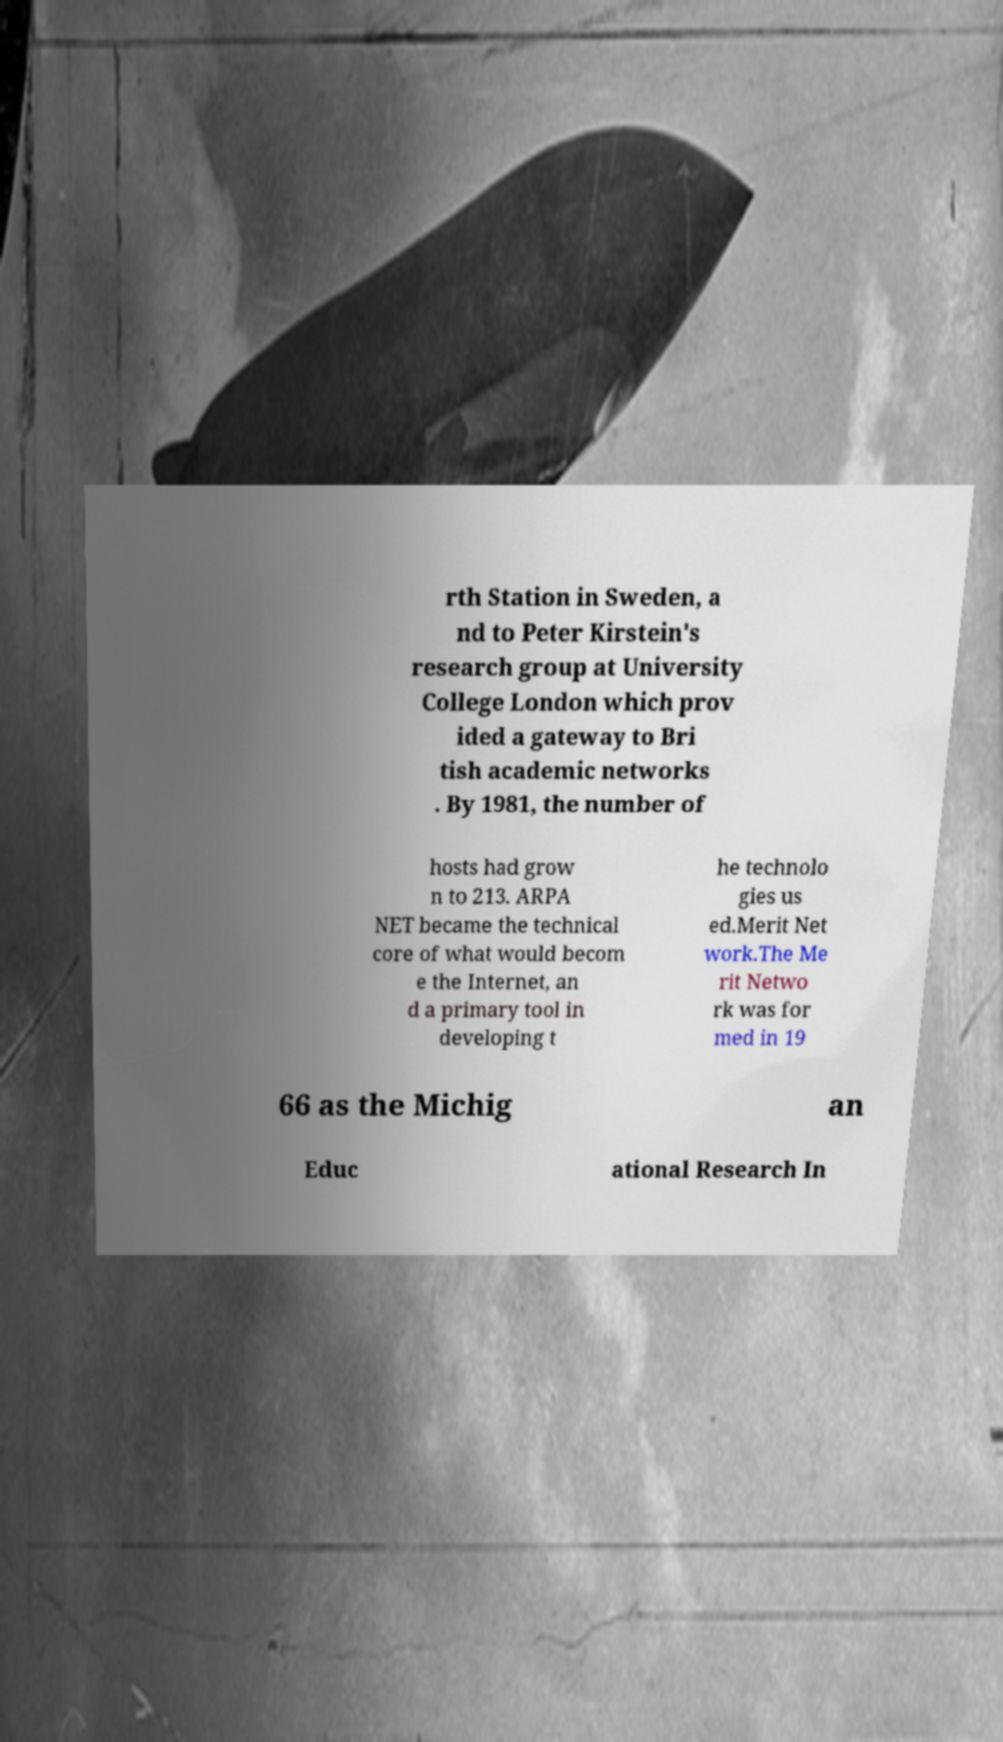Can you accurately transcribe the text from the provided image for me? rth Station in Sweden, a nd to Peter Kirstein's research group at University College London which prov ided a gateway to Bri tish academic networks . By 1981, the number of hosts had grow n to 213. ARPA NET became the technical core of what would becom e the Internet, an d a primary tool in developing t he technolo gies us ed.Merit Net work.The Me rit Netwo rk was for med in 19 66 as the Michig an Educ ational Research In 